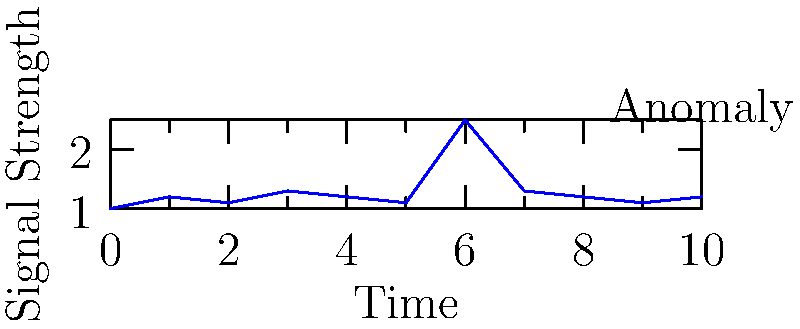In the radar signal time series data shown above, which statistical method would be most appropriate for detecting the anomaly at time t=6, considering the relatively stable baseline? To detect the anomaly in this radar signal time series, we need to consider the following steps:

1. Observe the data: The signal shows a relatively stable baseline around 1.1-1.3, with a sudden spike at t=6.

2. Understand the context: As a former military officer familiar with radar systems, you know that sudden spikes could indicate important events or potential threats.

3. Consider statistical methods:
   a) Moving average: Useful, but may not capture sudden spikes effectively.
   b) Standard deviation: Good for detecting outliers, but requires calculating mean and variance.
   c) Z-score: Effective for standardizing data and identifying outliers.
   d) CUSUM (Cumulative Sum): Good for detecting small shifts, but may be overly sensitive.

4. Analyze the best fit:
   The Z-score method would be most appropriate because:
   - It standardizes the data, making it easy to identify outliers.
   - It's sensitive to sudden spikes, which is crucial in radar signal analysis.
   - It's computationally efficient, allowing for real-time processing.

5. Calculate the Z-score:
   Z-score = (x - μ) / σ
   Where x is the data point, μ is the mean, and σ is the standard deviation.

6. Set a threshold:
   Typically, Z-scores above 3 or below -3 are considered anomalies.

The Z-score method would effectively highlight the anomaly at t=6, making it stand out from the baseline signal.
Answer: Z-score method 